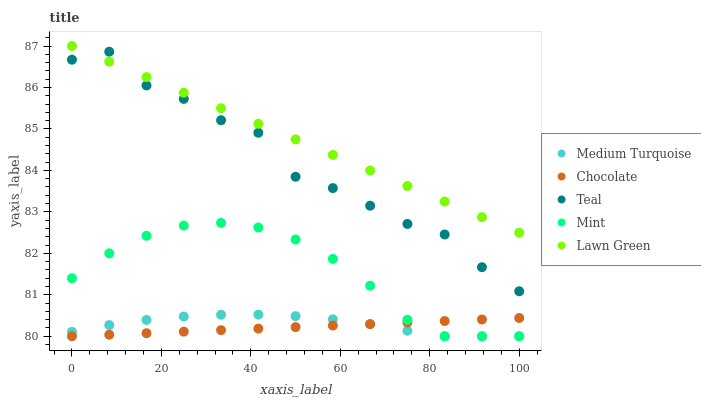Does Chocolate have the minimum area under the curve?
Answer yes or no. Yes. Does Lawn Green have the maximum area under the curve?
Answer yes or no. Yes. Does Mint have the minimum area under the curve?
Answer yes or no. No. Does Mint have the maximum area under the curve?
Answer yes or no. No. Is Chocolate the smoothest?
Answer yes or no. Yes. Is Teal the roughest?
Answer yes or no. Yes. Is Mint the smoothest?
Answer yes or no. No. Is Mint the roughest?
Answer yes or no. No. Does Mint have the lowest value?
Answer yes or no. Yes. Does Teal have the lowest value?
Answer yes or no. No. Does Lawn Green have the highest value?
Answer yes or no. Yes. Does Mint have the highest value?
Answer yes or no. No. Is Medium Turquoise less than Lawn Green?
Answer yes or no. Yes. Is Teal greater than Chocolate?
Answer yes or no. Yes. Does Medium Turquoise intersect Mint?
Answer yes or no. Yes. Is Medium Turquoise less than Mint?
Answer yes or no. No. Is Medium Turquoise greater than Mint?
Answer yes or no. No. Does Medium Turquoise intersect Lawn Green?
Answer yes or no. No. 